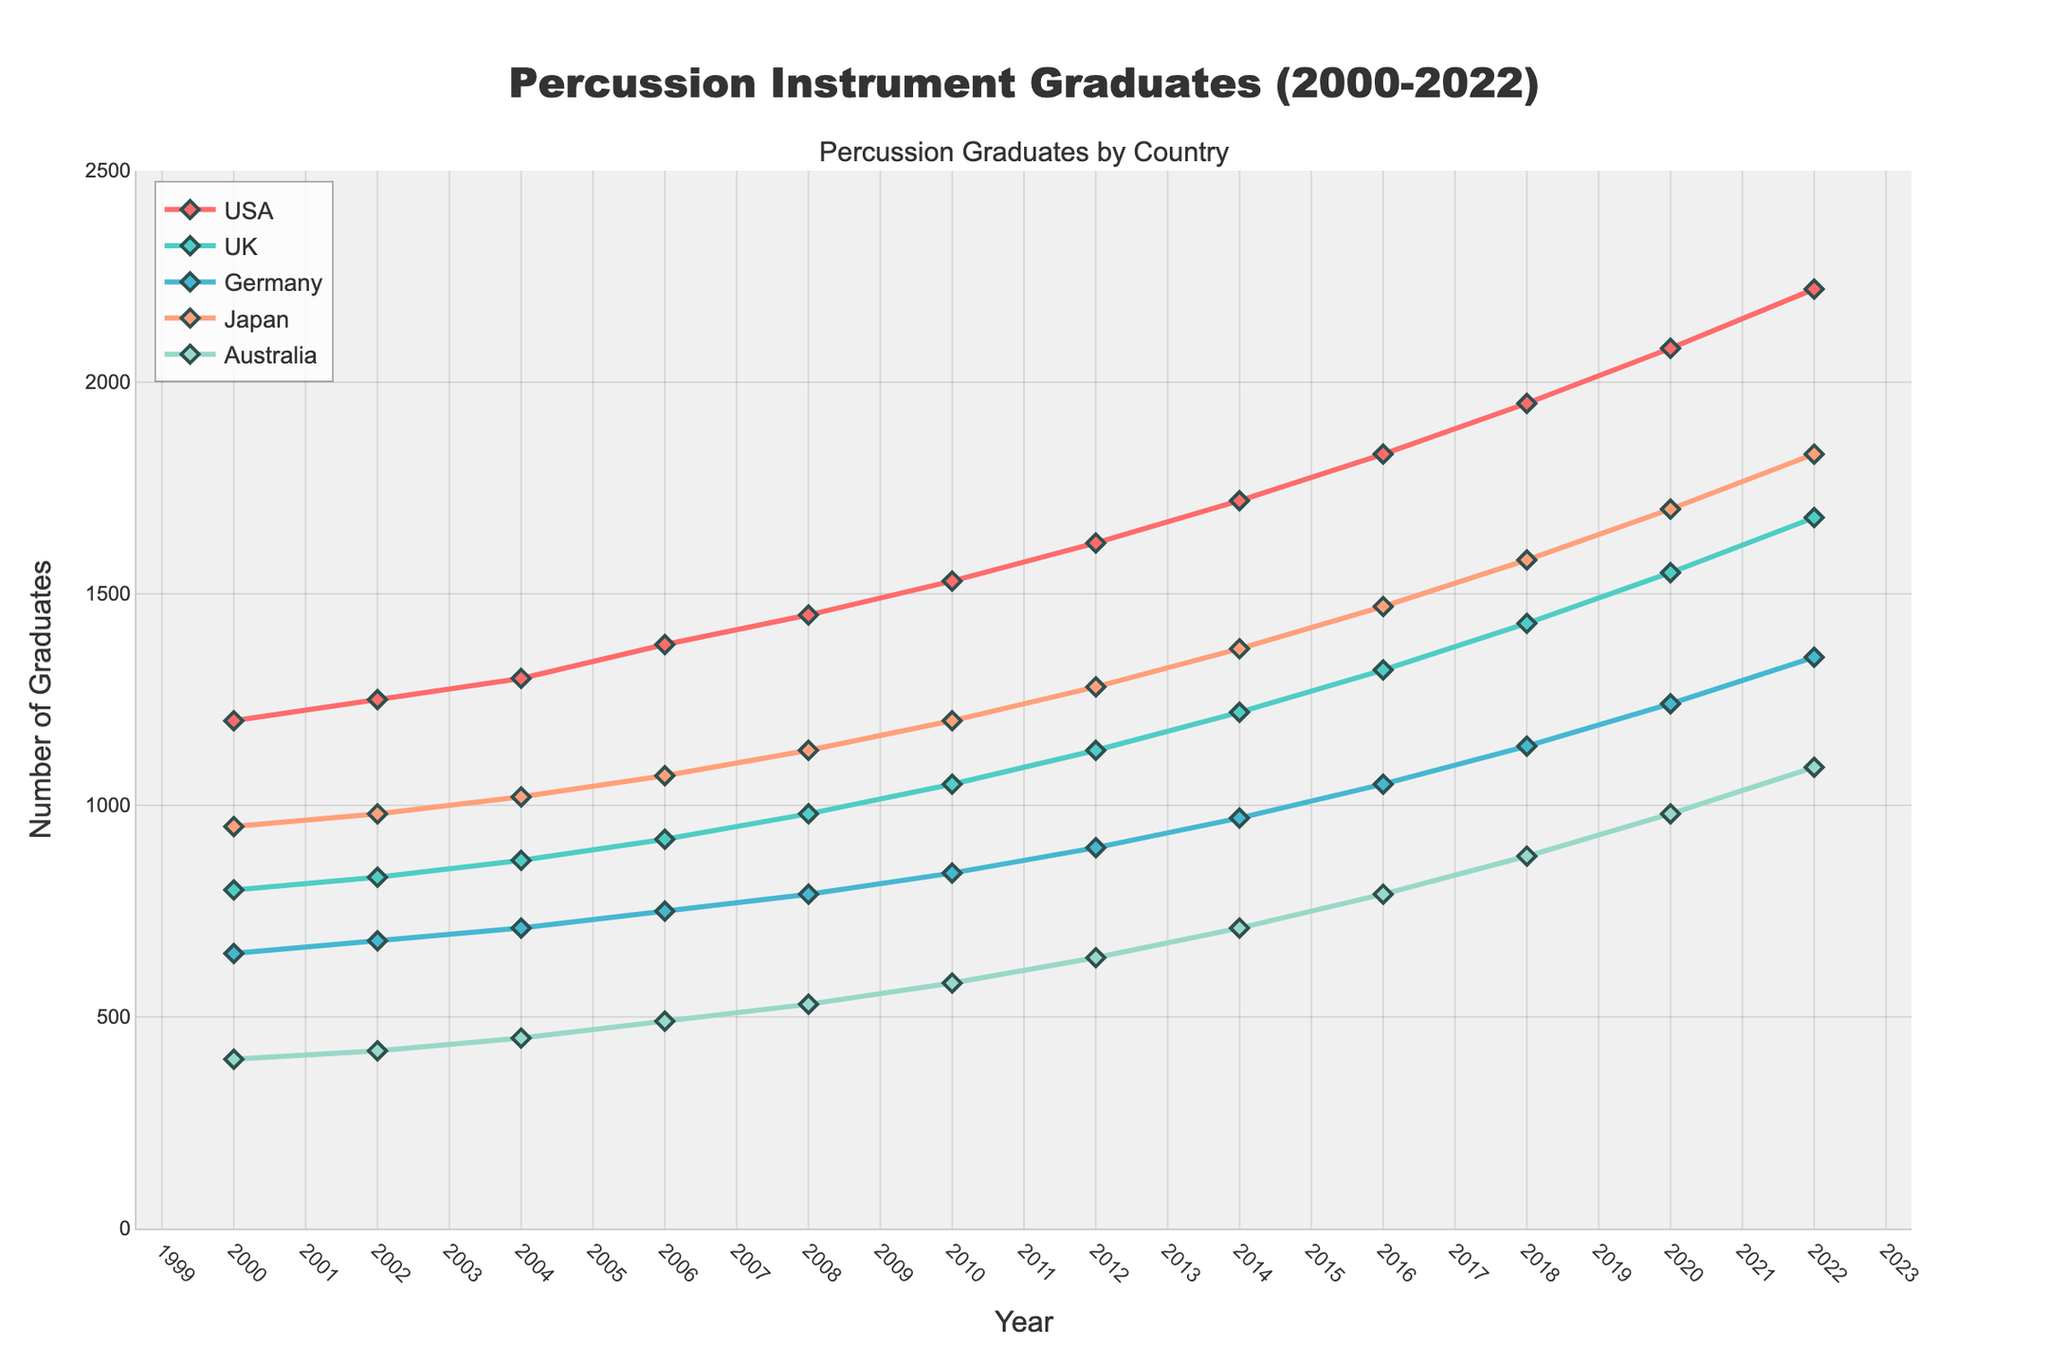what is the trend of the number of music school graduates specializing in percussion instruments in the USA from 2000 to 2022? To determine the trend, observe the trajectory of the USA line from 2000 to 2022. The number consistently increases from 1200 in 2000 to 2220 in 2022, indicating a steady upward trend.
Answer: Upward trend which country had the lowest number of percussion graduates in 2022? Look at the end of all lines in 2022. The line for Australia is the lowest, aligning with the value 1090.
Answer: Australia how much did the number of percussion graduates increase in Germany from 2000 to 2022? Subtract the number of graduates in 2000 (650) from the number in 2022 (1350) for Germany: 1350 - 650 = 700.
Answer: 700 in which year did Japan surpass Germany in the number of percussion graduates? Compare the values of Japan and Germany over the years. Japan (970) surpassed Germany (840) in 2010.
Answer: 2010 what is the average number of percussion graduates in the UK between 2000 and 2022? Add the values from 2000 to 2022 and divide by the number of years: (800 + 830 + 870 + 920 + 980 + 1050 + 1130 + 1220 + 1320 + 1430 + 1550 + 1680) / 12 = 1122.5.
Answer: 1122.5 which country had the highest growth rate in the number of percussion graduates from 2000 to 2022? Calculate the percentage increase for each country and compare. USA: (2220-1200)/1200=85%; UK: (1680-800)/800=110%; Germany: (1350-650)/650=107.7%; Japan: (1830-950)/950=92.6%; Australia: (1090-400)/400=172.5%. Australia has the highest growth rate.
Answer: Australia how do the trends of percussion graduates in the USA and UK compare from 2000 to 2022? Observe the overall patterns of both lines. Both show upward trends, but the USA has a steeper increase compared to the UK.
Answer: Both upward, USA steeper which year had the smallest increase in percussion graduates in the USA compared to the previous year? Observe the differences year by year for the USA. The smallest increase is 50 between 2000 (1200) and 2002 (1250).
Answer: 2002 between Germany and Australia, which country had more consistent growth in the number of percussion graduates? Compare the smoothness of the lines for Germany and Australia. Germany shows a more consistent, smoother growth, while Australia has a steeper, more varied increase.
Answer: Germany 